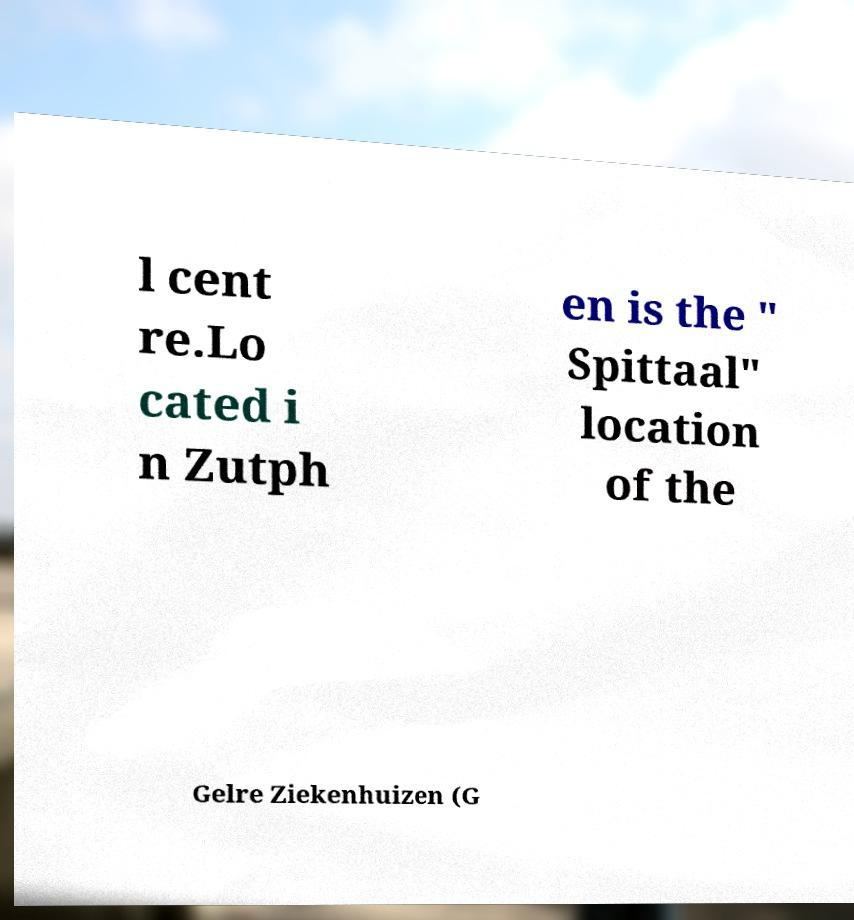Can you accurately transcribe the text from the provided image for me? l cent re.Lo cated i n Zutph en is the " Spittaal" location of the Gelre Ziekenhuizen (G 